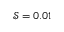<formula> <loc_0><loc_0><loc_500><loc_500>\mathcal { S } = 0 . 0 1</formula> 